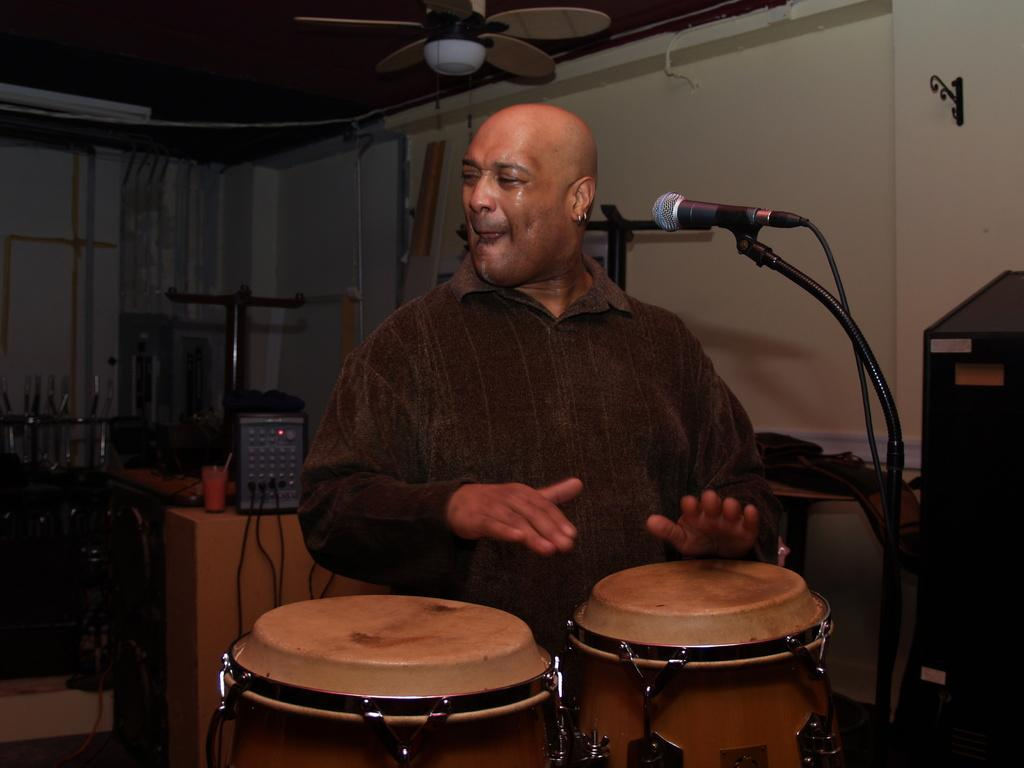What is the main subject of the image? The main subject of the image is a man. What is the man doing in the image? The man is playing drums in the image. Can you describe the man's position in the image? The man is standing in the image. What year is the train depicted in the image? There is no train present in the image, so it is not possible to determine the year. 